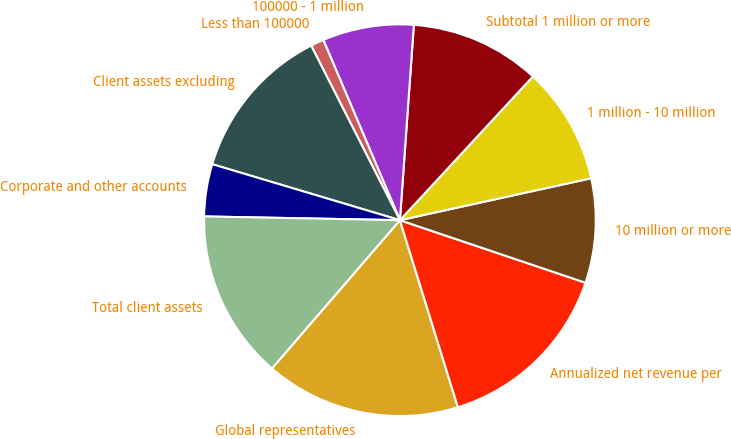Convert chart. <chart><loc_0><loc_0><loc_500><loc_500><pie_chart><fcel>Global representatives<fcel>Annualized net revenue per<fcel>10 million or more<fcel>1 million - 10 million<fcel>Subtotal 1 million or more<fcel>100000 - 1 million<fcel>Less than 100000<fcel>Client assets excluding<fcel>Corporate and other accounts<fcel>Total client assets<nl><fcel>16.12%<fcel>15.04%<fcel>8.61%<fcel>9.68%<fcel>10.75%<fcel>7.53%<fcel>1.09%<fcel>12.9%<fcel>4.31%<fcel>13.97%<nl></chart> 